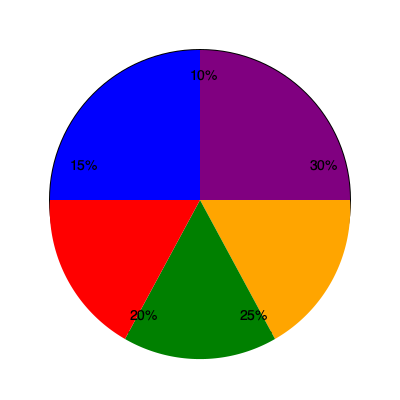As a nutritionist, analyze the pie chart representing macronutrient distribution in a meal. Which macronutrient is likely represented by the orange slice (30%), and how does this distribution align with general recommendations for a balanced meal? Additionally, propose a potential improvement to this macronutrient balance, if necessary. To answer this question, let's analyze the pie chart and consider general nutritional guidelines:

1. Identify the macronutrients:
   The three main macronutrients are carbohydrates, proteins, and fats.

2. Analyze the orange slice (30%):
   The largest portion is likely to represent carbohydrates, as they typically make up the largest percentage of a balanced meal.

3. Compare to general recommendations:
   A commonly recommended macronutrient distribution is:
   - Carbohydrates: 45-65% of total calories
   - Proteins: 10-35% of total calories
   - Fats: 20-35% of total calories

4. Evaluate the distribution:
   - Carbohydrates (orange, 30%): Lower than the recommended range
   - Proteins (likely green, 25%): Within the recommended range
   - Fats (likely red, 20%): Within the recommended range
   - The blue (15%) and purple (10%) slices might represent subcategories or additional components

5. Potential improvement:
   To better align with general recommendations, the carbohydrate portion could be increased to at least 45% of the total calories. This can be achieved by reducing the blue and purple portions (if they represent non-essential components) and slightly decreasing the protein portion while maintaining it within the recommended range.

It's important to note that individual dietary needs may vary based on factors such as age, sex, activity level, and health conditions. As a nutritionist, personalized recommendations would be made based on a comprehensive assessment of an individual's specific needs and goals.
Answer: The orange slice likely represents carbohydrates. The distribution is lower in carbohydrates than generally recommended. To improve, increase carbohydrates to at least 45% while maintaining protein and fat within recommended ranges. 